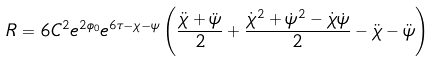Convert formula to latex. <formula><loc_0><loc_0><loc_500><loc_500>R = 6 C ^ { 2 } e ^ { 2 \phi _ { 0 } } e ^ { 6 \tau - \chi - \psi } \left ( \frac { \ddot { \chi } + \ddot { \psi } } { 2 } + \frac { \dot { \chi } ^ { 2 } + \dot { \psi } ^ { 2 } - \dot { \chi } \dot { \psi } } { 2 } - \ddot { \chi } - \ddot { \psi } \right )</formula> 